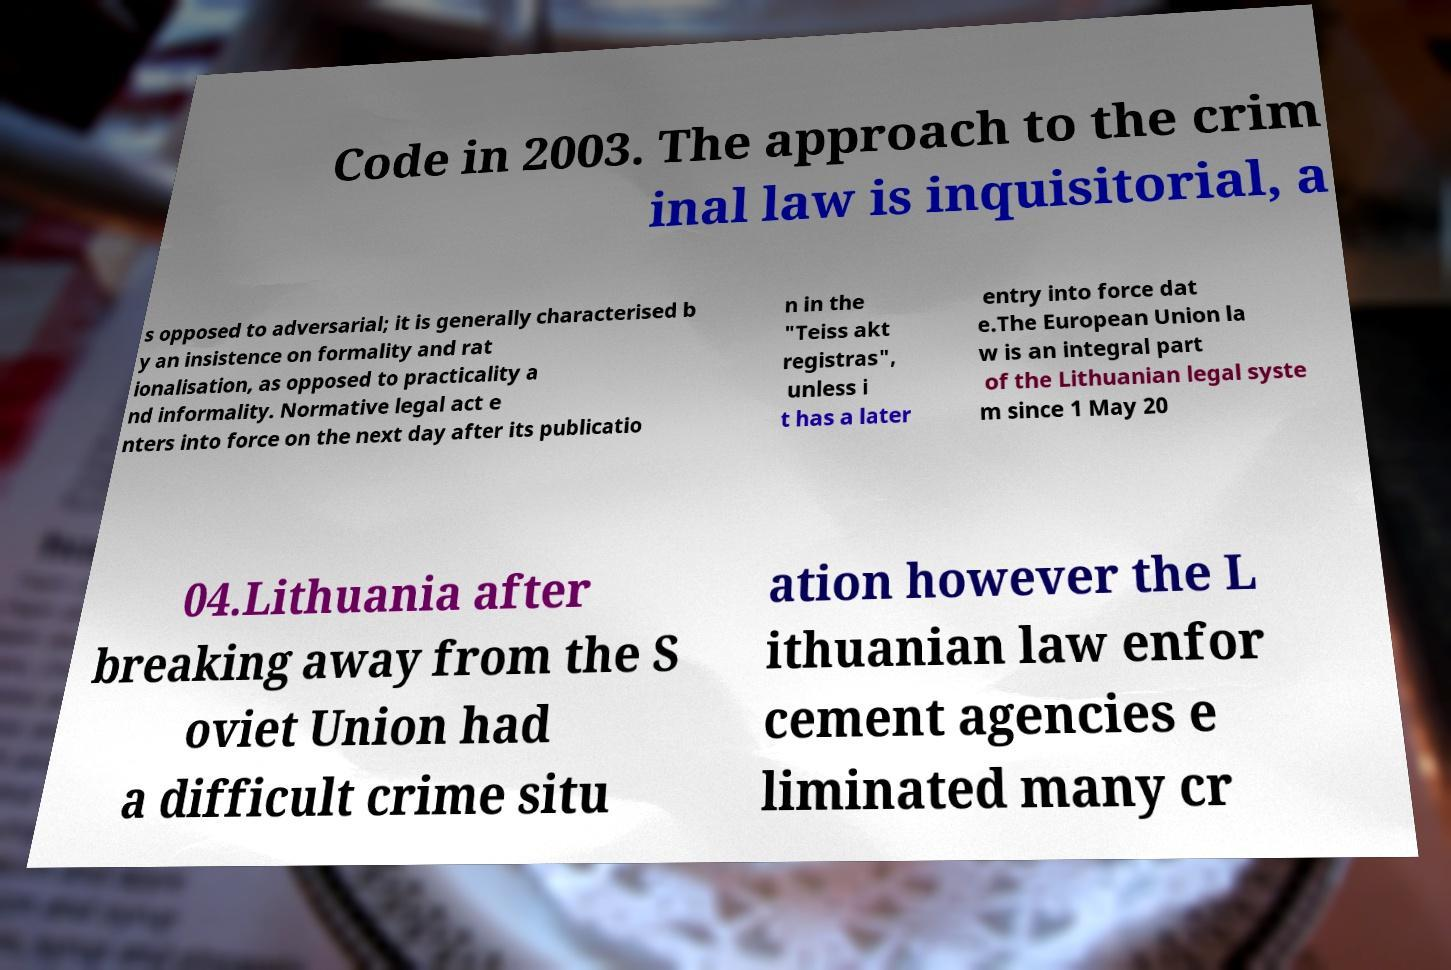Please read and relay the text visible in this image. What does it say? Code in 2003. The approach to the crim inal law is inquisitorial, a s opposed to adversarial; it is generally characterised b y an insistence on formality and rat ionalisation, as opposed to practicality a nd informality. Normative legal act e nters into force on the next day after its publicatio n in the "Teiss akt registras", unless i t has a later entry into force dat e.The European Union la w is an integral part of the Lithuanian legal syste m since 1 May 20 04.Lithuania after breaking away from the S oviet Union had a difficult crime situ ation however the L ithuanian law enfor cement agencies e liminated many cr 